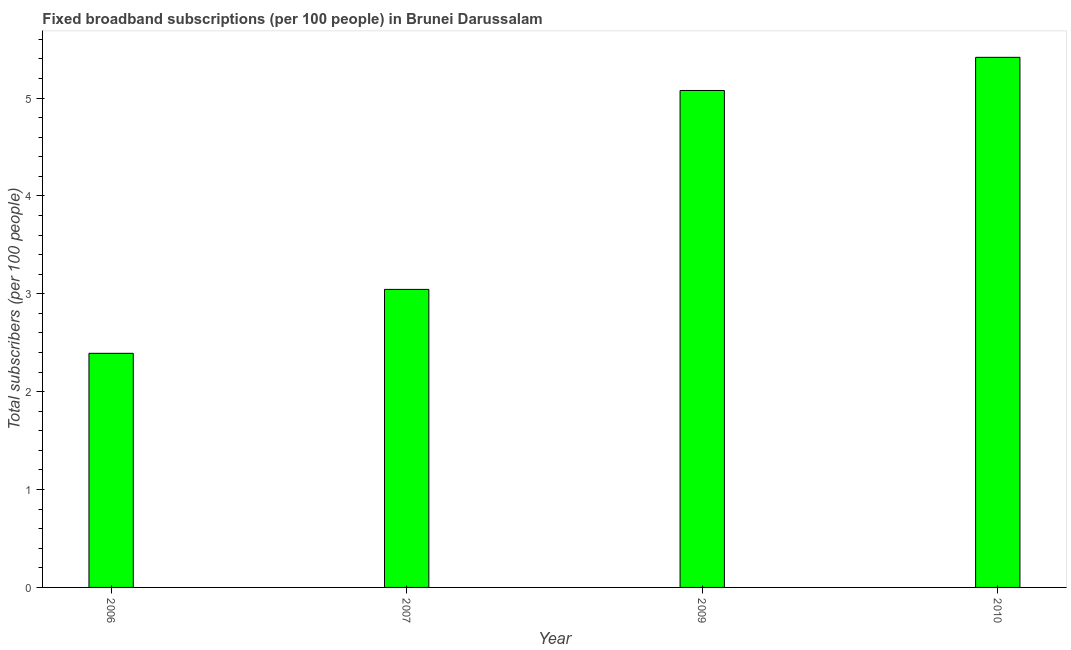Does the graph contain any zero values?
Make the answer very short. No. Does the graph contain grids?
Provide a succinct answer. No. What is the title of the graph?
Provide a short and direct response. Fixed broadband subscriptions (per 100 people) in Brunei Darussalam. What is the label or title of the X-axis?
Offer a terse response. Year. What is the label or title of the Y-axis?
Give a very brief answer. Total subscribers (per 100 people). What is the total number of fixed broadband subscriptions in 2007?
Your response must be concise. 3.05. Across all years, what is the maximum total number of fixed broadband subscriptions?
Your answer should be very brief. 5.42. Across all years, what is the minimum total number of fixed broadband subscriptions?
Offer a terse response. 2.39. In which year was the total number of fixed broadband subscriptions maximum?
Ensure brevity in your answer.  2010. What is the sum of the total number of fixed broadband subscriptions?
Make the answer very short. 15.93. What is the difference between the total number of fixed broadband subscriptions in 2007 and 2009?
Make the answer very short. -2.03. What is the average total number of fixed broadband subscriptions per year?
Your answer should be compact. 3.98. What is the median total number of fixed broadband subscriptions?
Offer a very short reply. 4.06. In how many years, is the total number of fixed broadband subscriptions greater than 1.8 ?
Keep it short and to the point. 4. What is the ratio of the total number of fixed broadband subscriptions in 2006 to that in 2007?
Your answer should be compact. 0.79. Is the difference between the total number of fixed broadband subscriptions in 2006 and 2007 greater than the difference between any two years?
Your answer should be compact. No. What is the difference between the highest and the second highest total number of fixed broadband subscriptions?
Your answer should be very brief. 0.34. Is the sum of the total number of fixed broadband subscriptions in 2006 and 2009 greater than the maximum total number of fixed broadband subscriptions across all years?
Keep it short and to the point. Yes. What is the difference between the highest and the lowest total number of fixed broadband subscriptions?
Offer a very short reply. 3.02. Are all the bars in the graph horizontal?
Offer a very short reply. No. What is the difference between two consecutive major ticks on the Y-axis?
Provide a short and direct response. 1. Are the values on the major ticks of Y-axis written in scientific E-notation?
Offer a terse response. No. What is the Total subscribers (per 100 people) in 2006?
Make the answer very short. 2.39. What is the Total subscribers (per 100 people) of 2007?
Provide a succinct answer. 3.05. What is the Total subscribers (per 100 people) in 2009?
Offer a terse response. 5.08. What is the Total subscribers (per 100 people) in 2010?
Your response must be concise. 5.42. What is the difference between the Total subscribers (per 100 people) in 2006 and 2007?
Provide a succinct answer. -0.65. What is the difference between the Total subscribers (per 100 people) in 2006 and 2009?
Your answer should be compact. -2.69. What is the difference between the Total subscribers (per 100 people) in 2006 and 2010?
Give a very brief answer. -3.02. What is the difference between the Total subscribers (per 100 people) in 2007 and 2009?
Your response must be concise. -2.03. What is the difference between the Total subscribers (per 100 people) in 2007 and 2010?
Offer a terse response. -2.37. What is the difference between the Total subscribers (per 100 people) in 2009 and 2010?
Provide a succinct answer. -0.34. What is the ratio of the Total subscribers (per 100 people) in 2006 to that in 2007?
Keep it short and to the point. 0.79. What is the ratio of the Total subscribers (per 100 people) in 2006 to that in 2009?
Provide a succinct answer. 0.47. What is the ratio of the Total subscribers (per 100 people) in 2006 to that in 2010?
Keep it short and to the point. 0.44. What is the ratio of the Total subscribers (per 100 people) in 2007 to that in 2009?
Keep it short and to the point. 0.6. What is the ratio of the Total subscribers (per 100 people) in 2007 to that in 2010?
Offer a very short reply. 0.56. What is the ratio of the Total subscribers (per 100 people) in 2009 to that in 2010?
Make the answer very short. 0.94. 